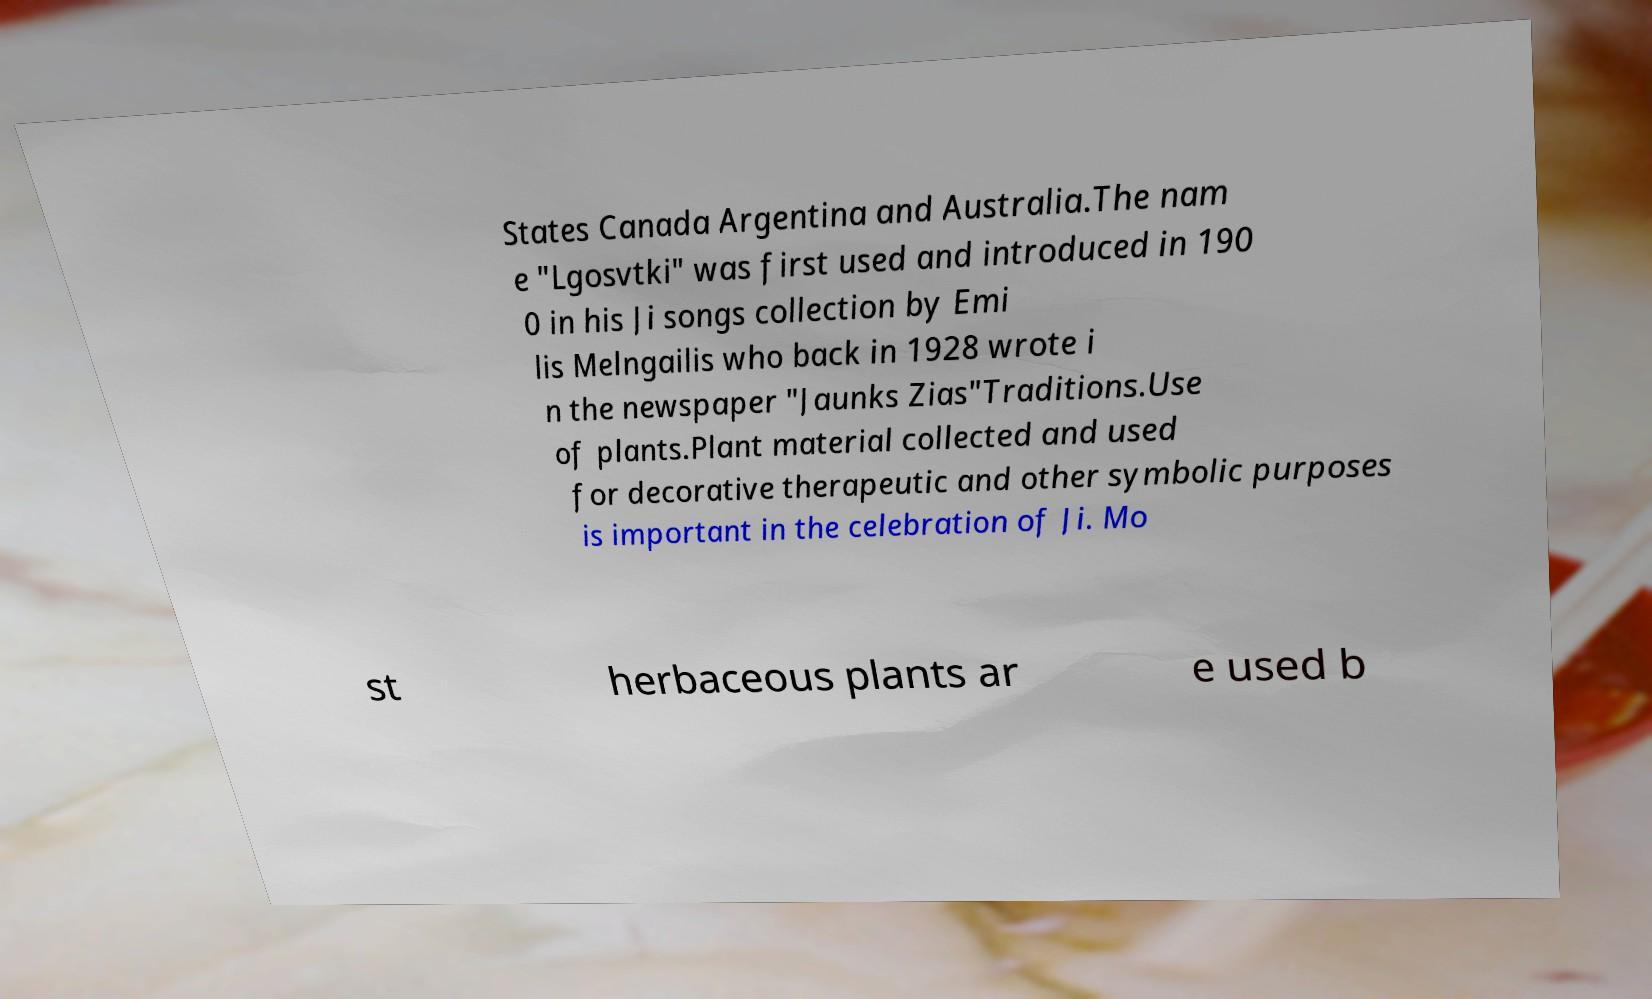Please identify and transcribe the text found in this image. States Canada Argentina and Australia.The nam e "Lgosvtki" was first used and introduced in 190 0 in his Ji songs collection by Emi lis Melngailis who back in 1928 wrote i n the newspaper "Jaunks Zias"Traditions.Use of plants.Plant material collected and used for decorative therapeutic and other symbolic purposes is important in the celebration of Ji. Mo st herbaceous plants ar e used b 